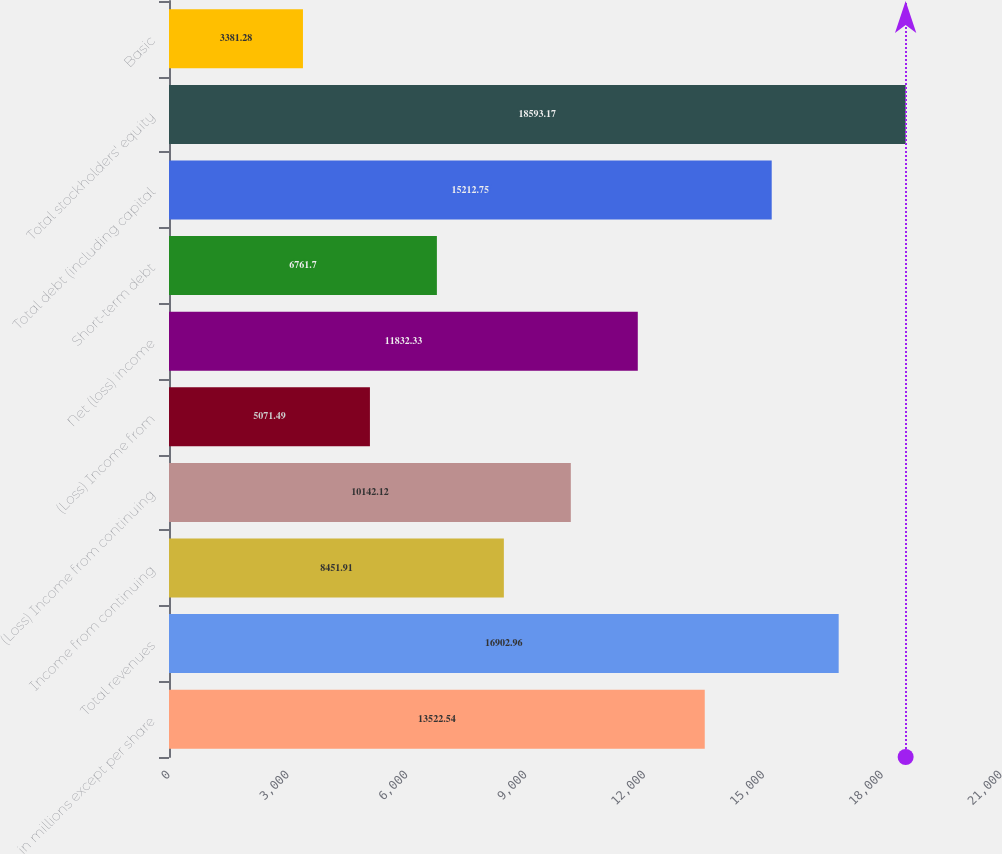Convert chart. <chart><loc_0><loc_0><loc_500><loc_500><bar_chart><fcel>in millions except per share<fcel>Total revenues<fcel>Income from continuing<fcel>(Loss) Income from continuing<fcel>(Loss) Income from<fcel>Net (loss) income<fcel>Short-term debt<fcel>Total debt (including capital<fcel>Total stockholders' equity<fcel>Basic<nl><fcel>13522.5<fcel>16903<fcel>8451.91<fcel>10142.1<fcel>5071.49<fcel>11832.3<fcel>6761.7<fcel>15212.8<fcel>18593.2<fcel>3381.28<nl></chart> 